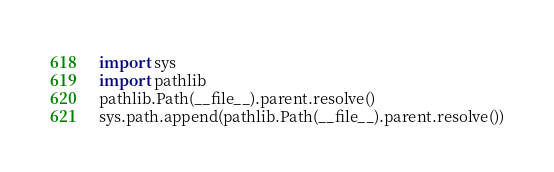<code> <loc_0><loc_0><loc_500><loc_500><_Python_>import sys
import pathlib
pathlib.Path(__file__).parent.resolve()
sys.path.append(pathlib.Path(__file__).parent.resolve())
</code> 